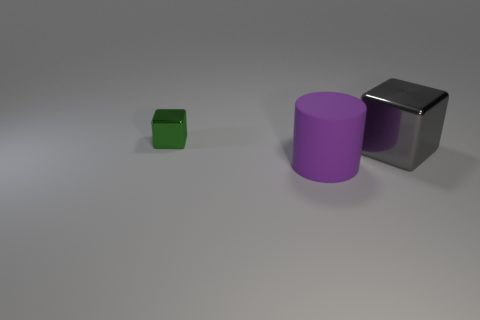Add 3 green metal objects. How many objects exist? 6 Subtract all blocks. How many objects are left? 1 Subtract 0 green cylinders. How many objects are left? 3 Subtract all gray shiny objects. Subtract all brown rubber cubes. How many objects are left? 2 Add 1 cylinders. How many cylinders are left? 2 Add 2 small objects. How many small objects exist? 3 